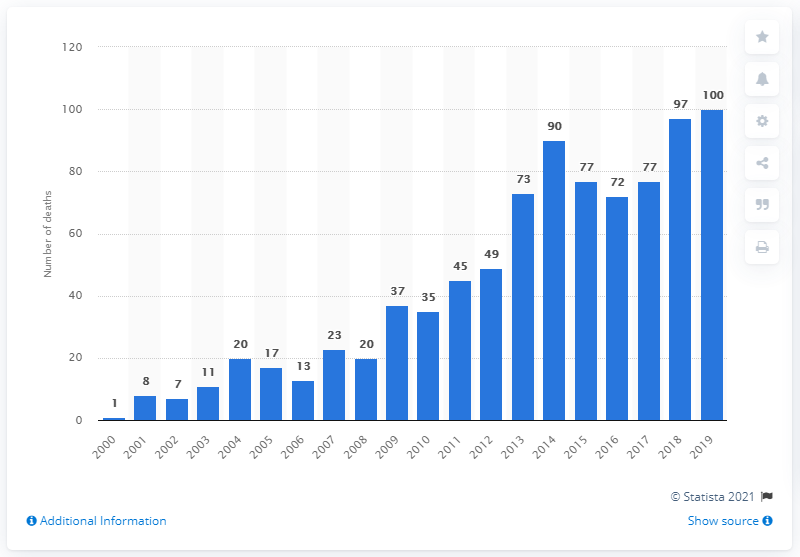Highlight a few significant elements in this photo. In the year 2000, there was a reported case of mirtazapine poisoning in England and Wales. In 2019, there were 100 deaths attributed to the drug mirtazapine. 